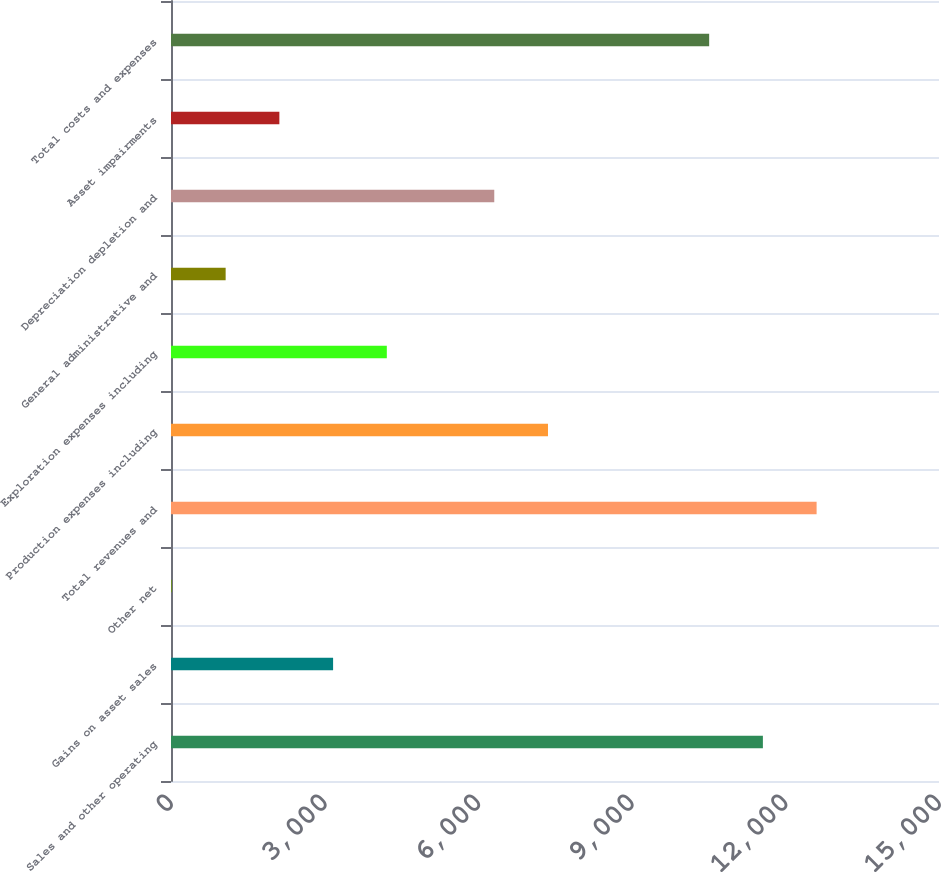Convert chart. <chart><loc_0><loc_0><loc_500><loc_500><bar_chart><fcel>Sales and other operating<fcel>Gains on asset sales<fcel>Other net<fcel>Total revenues and<fcel>Production expenses including<fcel>Exploration expenses including<fcel>General administrative and<fcel>Depreciation depletion and<fcel>Asset impairments<fcel>Total costs and expenses<nl><fcel>11560.3<fcel>3165.9<fcel>18<fcel>12609.6<fcel>7363.1<fcel>4215.2<fcel>1067.3<fcel>6313.8<fcel>2116.6<fcel>10511<nl></chart> 